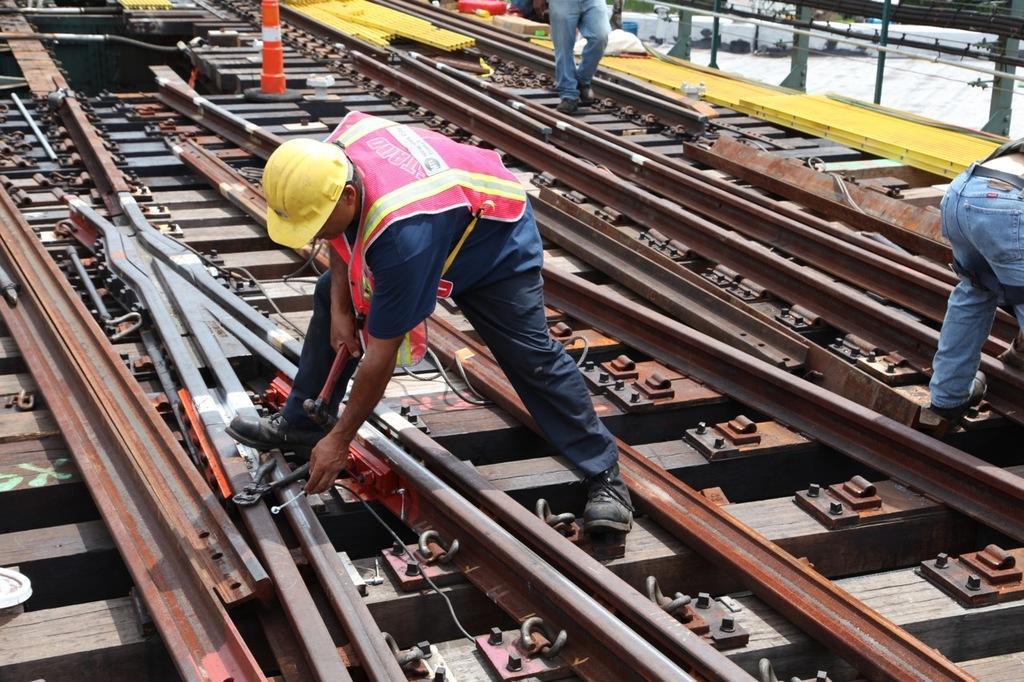Describe this image in one or two sentences. In this picture I can see railway tracks, there are three persons, there is a person repairing a railway track, and in the background there are some objects. 